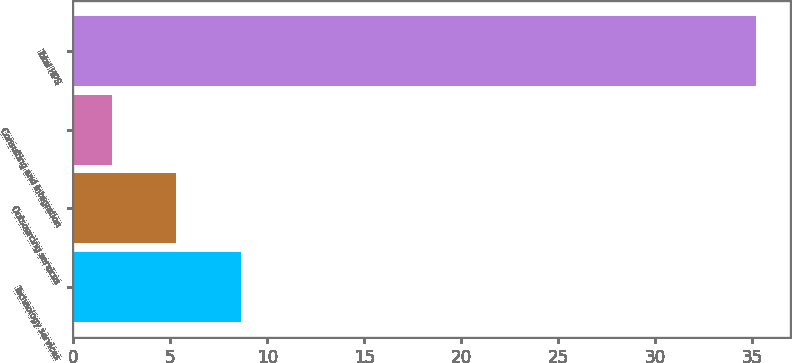Convert chart to OTSL. <chart><loc_0><loc_0><loc_500><loc_500><bar_chart><fcel>Technology services<fcel>Outsourcing services<fcel>Consulting and integration<fcel>Total HPS<nl><fcel>8.64<fcel>5.32<fcel>2<fcel>35.2<nl></chart> 